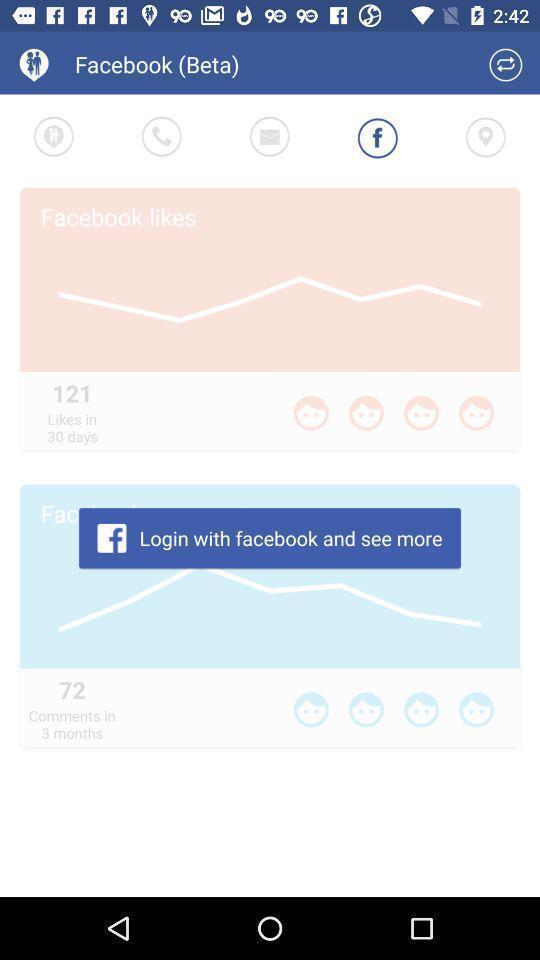Summarize the main components in this picture. Screen displaying login page. 